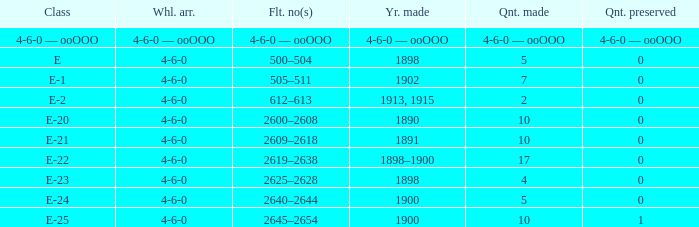Which fleet number is associated with a 4-6-0 wheel layout manufactured in 1890? 2600–2608. 